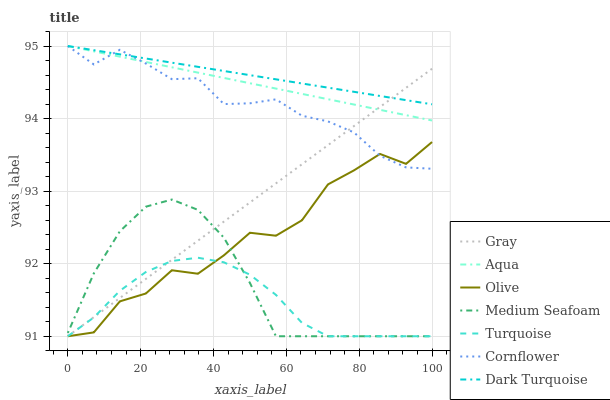Does Turquoise have the minimum area under the curve?
Answer yes or no. Yes. Does Dark Turquoise have the maximum area under the curve?
Answer yes or no. Yes. Does Cornflower have the minimum area under the curve?
Answer yes or no. No. Does Cornflower have the maximum area under the curve?
Answer yes or no. No. Is Gray the smoothest?
Answer yes or no. Yes. Is Olive the roughest?
Answer yes or no. Yes. Is Turquoise the smoothest?
Answer yes or no. No. Is Turquoise the roughest?
Answer yes or no. No. Does Gray have the lowest value?
Answer yes or no. Yes. Does Cornflower have the lowest value?
Answer yes or no. No. Does Aqua have the highest value?
Answer yes or no. Yes. Does Turquoise have the highest value?
Answer yes or no. No. Is Turquoise less than Cornflower?
Answer yes or no. Yes. Is Aqua greater than Olive?
Answer yes or no. Yes. Does Medium Seafoam intersect Olive?
Answer yes or no. Yes. Is Medium Seafoam less than Olive?
Answer yes or no. No. Is Medium Seafoam greater than Olive?
Answer yes or no. No. Does Turquoise intersect Cornflower?
Answer yes or no. No. 